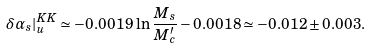<formula> <loc_0><loc_0><loc_500><loc_500>\delta \alpha _ { s } | _ { u } ^ { K K } \simeq - 0 . 0 0 1 9 \, \ln \frac { M _ { s } } { M _ { c } ^ { \prime } } - 0 . 0 0 1 8 \simeq - 0 . 0 1 2 \pm 0 . 0 0 3 .</formula> 